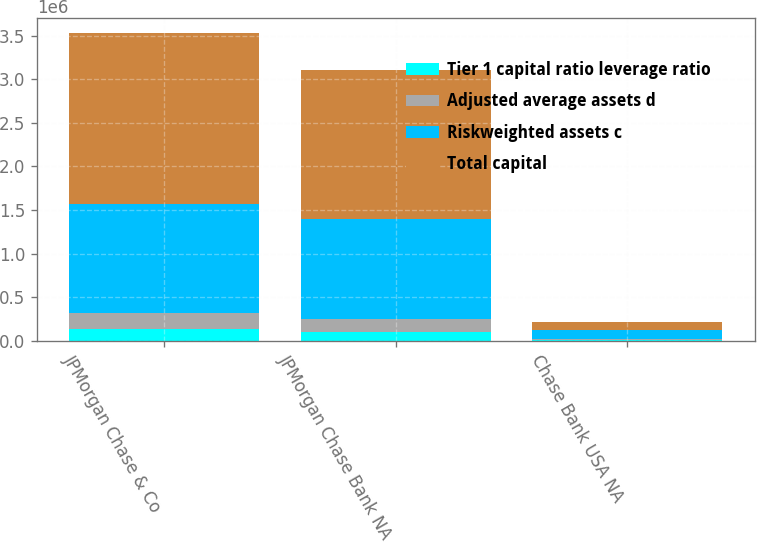Convert chart to OTSL. <chart><loc_0><loc_0><loc_500><loc_500><stacked_bar_chart><ecel><fcel>JPMorgan Chase & Co<fcel>JPMorgan Chase Bank NA<fcel>Chase Bank USA NA<nl><fcel>Tier 1 capital ratio leverage ratio<fcel>136104<fcel>100594<fcel>11190<nl><fcel>Adjusted average assets d<fcel>184720<fcel>143854<fcel>12901<nl><fcel>Riskweighted assets c<fcel>1.24466e+06<fcel>1.15304e+06<fcel>101472<nl><fcel>Total capital<fcel>1.9669e+06<fcel>1.70575e+06<fcel>87286<nl></chart> 